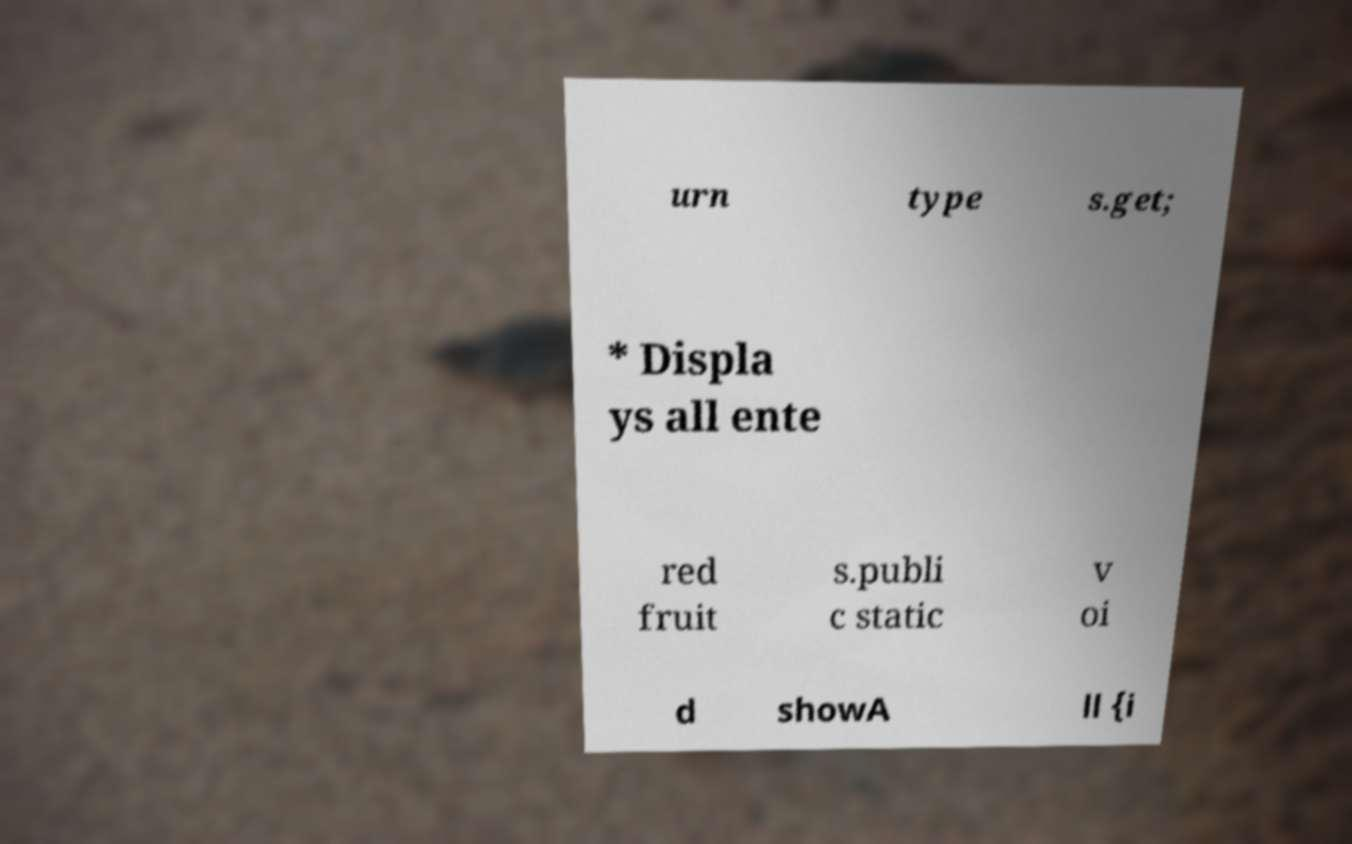There's text embedded in this image that I need extracted. Can you transcribe it verbatim? urn type s.get; * Displa ys all ente red fruit s.publi c static v oi d showA ll {i 